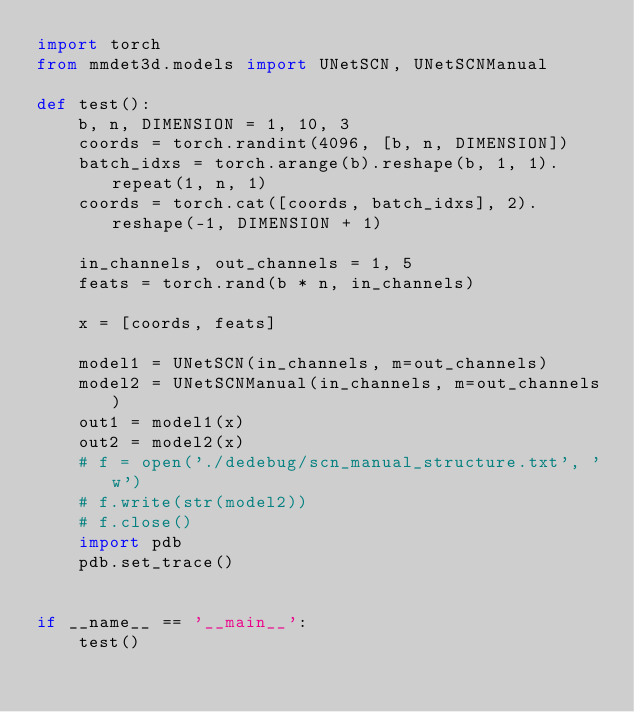Convert code to text. <code><loc_0><loc_0><loc_500><loc_500><_Python_>import torch
from mmdet3d.models import UNetSCN, UNetSCNManual

def test():
    b, n, DIMENSION = 1, 10, 3
    coords = torch.randint(4096, [b, n, DIMENSION])
    batch_idxs = torch.arange(b).reshape(b, 1, 1).repeat(1, n, 1)
    coords = torch.cat([coords, batch_idxs], 2).reshape(-1, DIMENSION + 1)

    in_channels, out_channels = 1, 5
    feats = torch.rand(b * n, in_channels)

    x = [coords, feats]

    model1 = UNetSCN(in_channels, m=out_channels)
    model2 = UNetSCNManual(in_channels, m=out_channels)
    out1 = model1(x)
    out2 = model2(x)
    # f = open('./dedebug/scn_manual_structure.txt', 'w')
    # f.write(str(model2))
    # f.close()
    import pdb
    pdb.set_trace()


if __name__ == '__main__':
    test()
</code> 